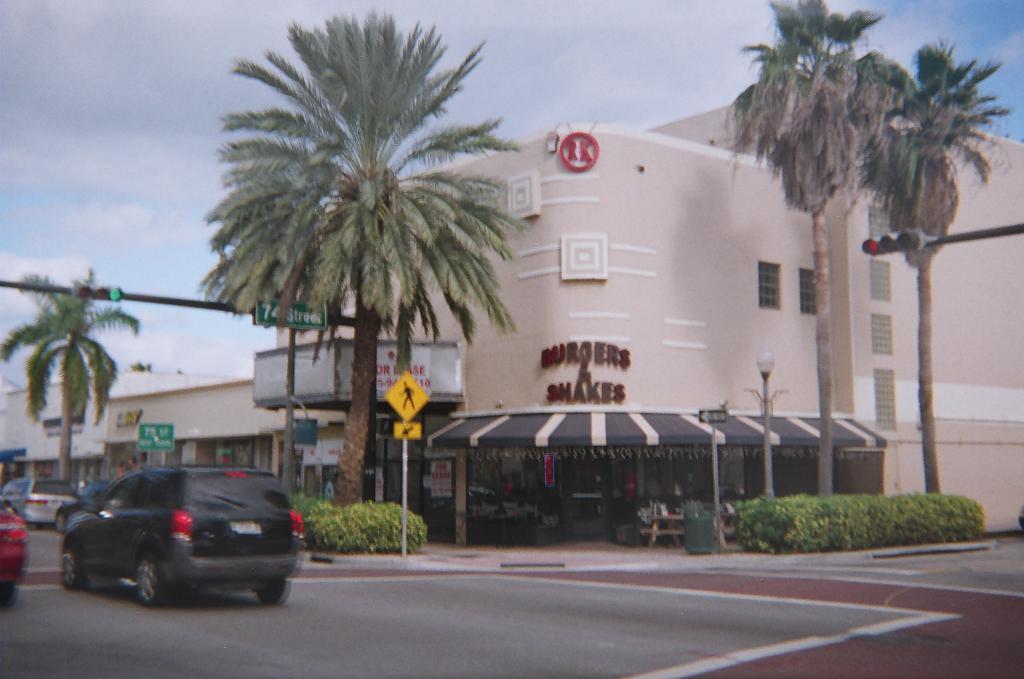How would you summarize this image in a sentence or two? In the picture we can see a road on it, we can see a car which is black in color and in front of it, we can see some cars and beside it, we can see a shed and two trees, traffic light to the pole and behind it, we can see the building and beside it we can see two trees, traffic light to the pole and in the background we can see the sky with clouds. 